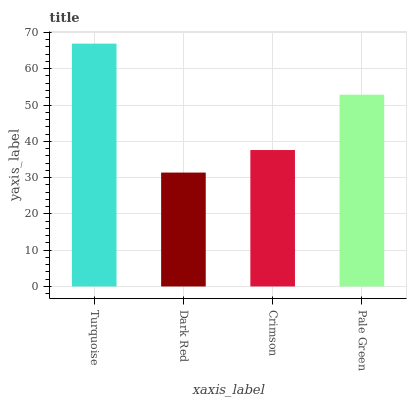Is Dark Red the minimum?
Answer yes or no. Yes. Is Turquoise the maximum?
Answer yes or no. Yes. Is Crimson the minimum?
Answer yes or no. No. Is Crimson the maximum?
Answer yes or no. No. Is Crimson greater than Dark Red?
Answer yes or no. Yes. Is Dark Red less than Crimson?
Answer yes or no. Yes. Is Dark Red greater than Crimson?
Answer yes or no. No. Is Crimson less than Dark Red?
Answer yes or no. No. Is Pale Green the high median?
Answer yes or no. Yes. Is Crimson the low median?
Answer yes or no. Yes. Is Turquoise the high median?
Answer yes or no. No. Is Turquoise the low median?
Answer yes or no. No. 